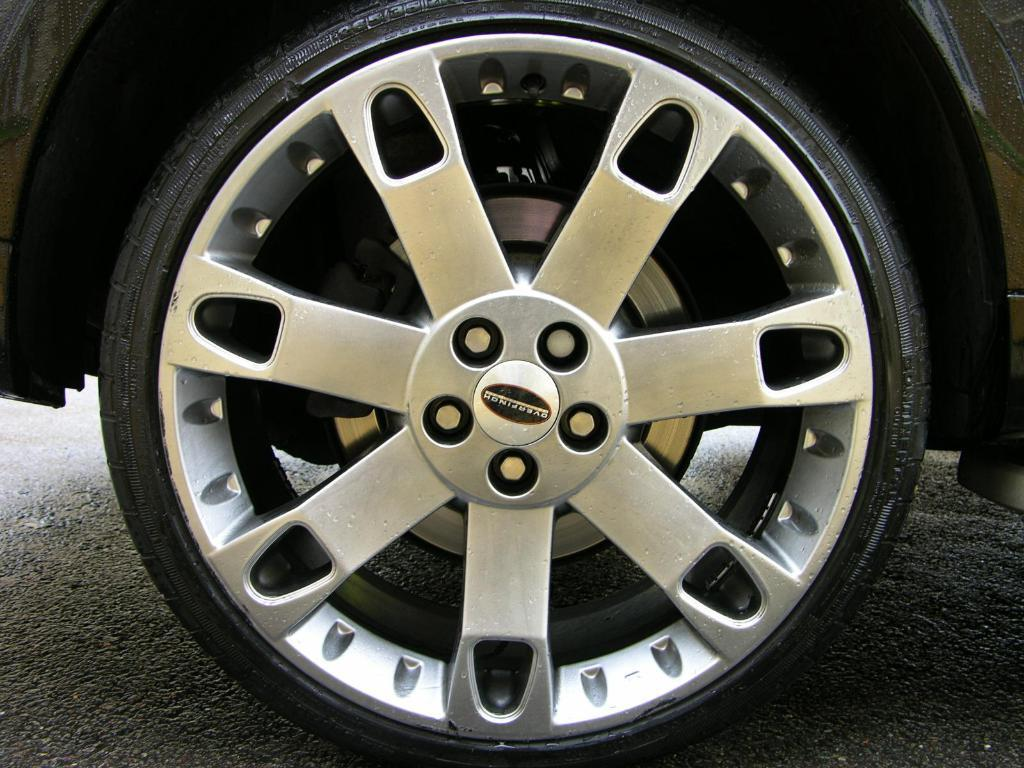What object can be seen in the image? There is a car tyre in the image. What type of surface is visible at the bottom of the image? There is a road visible at the bottom of the image. Can you see any windows in the image? There are no windows present in the image. Is there a tent visible in the image? There is no tent present in the image. 